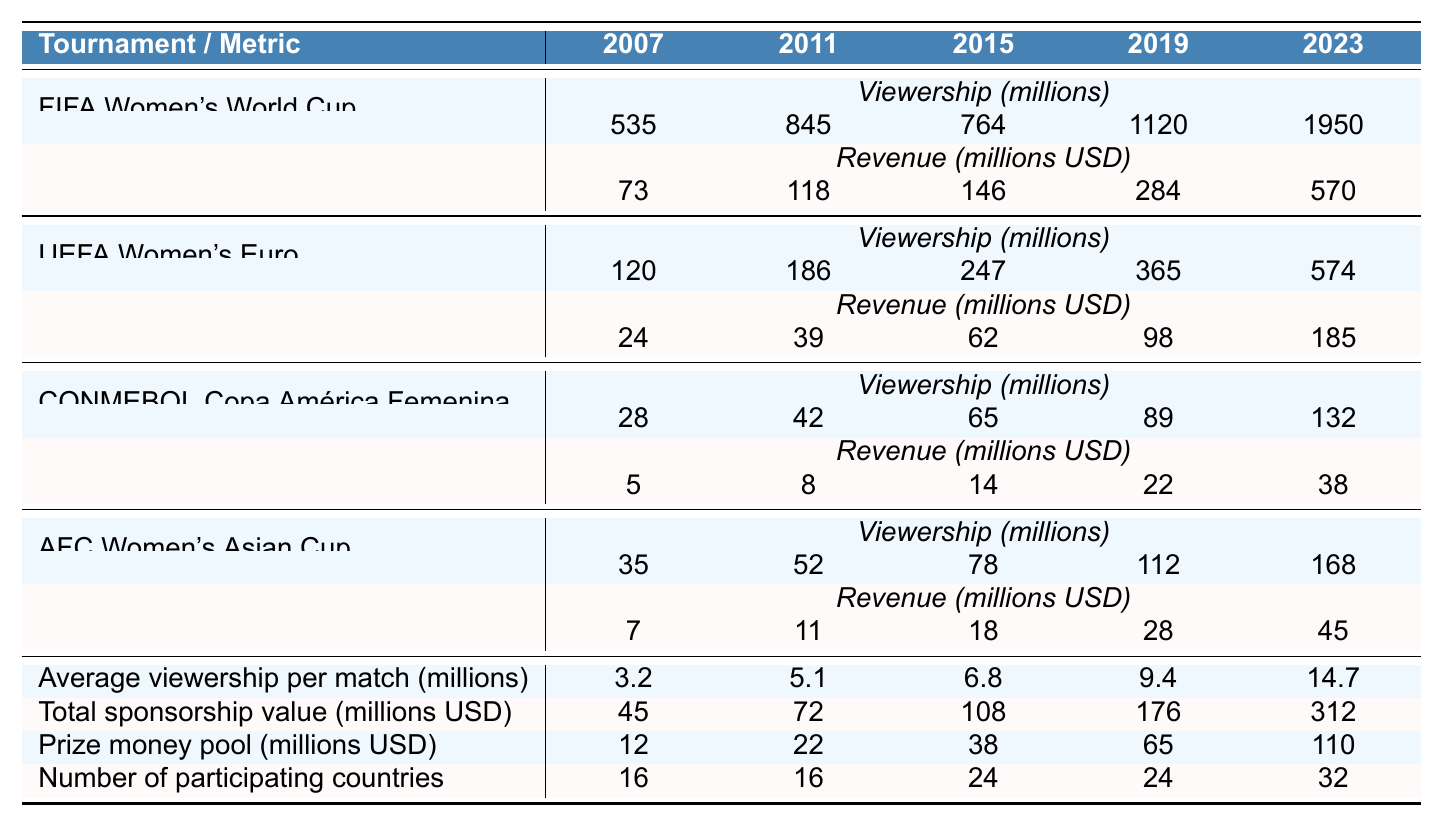What was the viewership of the FIFA Women's World Cup in 2023? The table indicates that the viewership of the FIFA Women's World Cup in 2023 is 1950 million.
Answer: 1950 million What is the total revenue from the UEFA Women's Euro in 2015 and 2019? The revenue for UEFA Women's Euro in 2015 is 62 million and in 2019 is 98 million. Adding them gives 62 + 98 = 160 million.
Answer: 160 million Did the viewership of the CONMEBOL Copa América Femenina increase from 2015 to 2019? The viewership for 2015 is 65 million and for 2019 it is 89 million. Since 89 is greater than 65, the viewership did increase.
Answer: Yes Which tournament had the highest increase in viewership from 2019 to 2023? The FIFA Women's World Cup had a viewership of 1120 million in 2019 and 1950 million in 2023, increasing by 830 million. The UEFA Women's Euro had an increase from 365 million to 574 million, amounting to 209 million. Thus, FIFA Women's World Cup had the highest increase.
Answer: FIFA Women's World Cup What is the average viewership per match in 2023 compared to 2019? The average viewership per match in 2023 is 14.7 million and in 2019 is 9.4 million. The difference is 14.7 - 9.4 = 5.3 million, indicating an increase.
Answer: Increase of 5.3 million What was the trend in prize money pool from 2007 to 2023? The prize money pool increased from 12 million in 2007 to 110 million in 2023. To determine the trend, we can see that this is a consistent increase over the years. Calculating the differences year by year confirms that it increased every time.
Answer: Consistent increase Was the average viewership per match higher in 2023 than in 2015? The average viewership per match in 2023 is 14.7 million, and in 2015, it was 6.8 million. Since 14.7 is greater than 6.8, it is higher in 2023.
Answer: Yes What is the total viewership for the AFC Women's Asian Cup from 2007 to 2023? The viewerships for the AFC Women's Asian Cup over these years are 35, 52, 78, 112, and 168 million. Summing those gives 35 + 52 + 78 + 112 + 168 = 445 million.
Answer: 445 million What percentage of the total revenue was generated by the FIFA Women's World Cup in 2023 compared to all tournaments in that year? The total revenue for all tournaments in 2023 is 570 (FIFA) + 185 (UEFA) + 38 (CONMEBOL) + 45 (AFC) = 838 million. The percentage of FIFA Women's World Cup revenue is (570 / 838) * 100 = 68.0%.
Answer: 68.0% Do more countries participate in the FIFA Women's World Cup in 2023 than in 2007? The number of participating countries in 2023 is 32, while in 2007 it was 16. Since 32 is greater than 16, more countries participate in 2023.
Answer: Yes What was the increase in total sponsorship value from 2019 to 2023? The total sponsorship value in 2019 was 176 million and in 2023 was 312 million. The increase is 312 - 176 = 136 million.
Answer: 136 million 